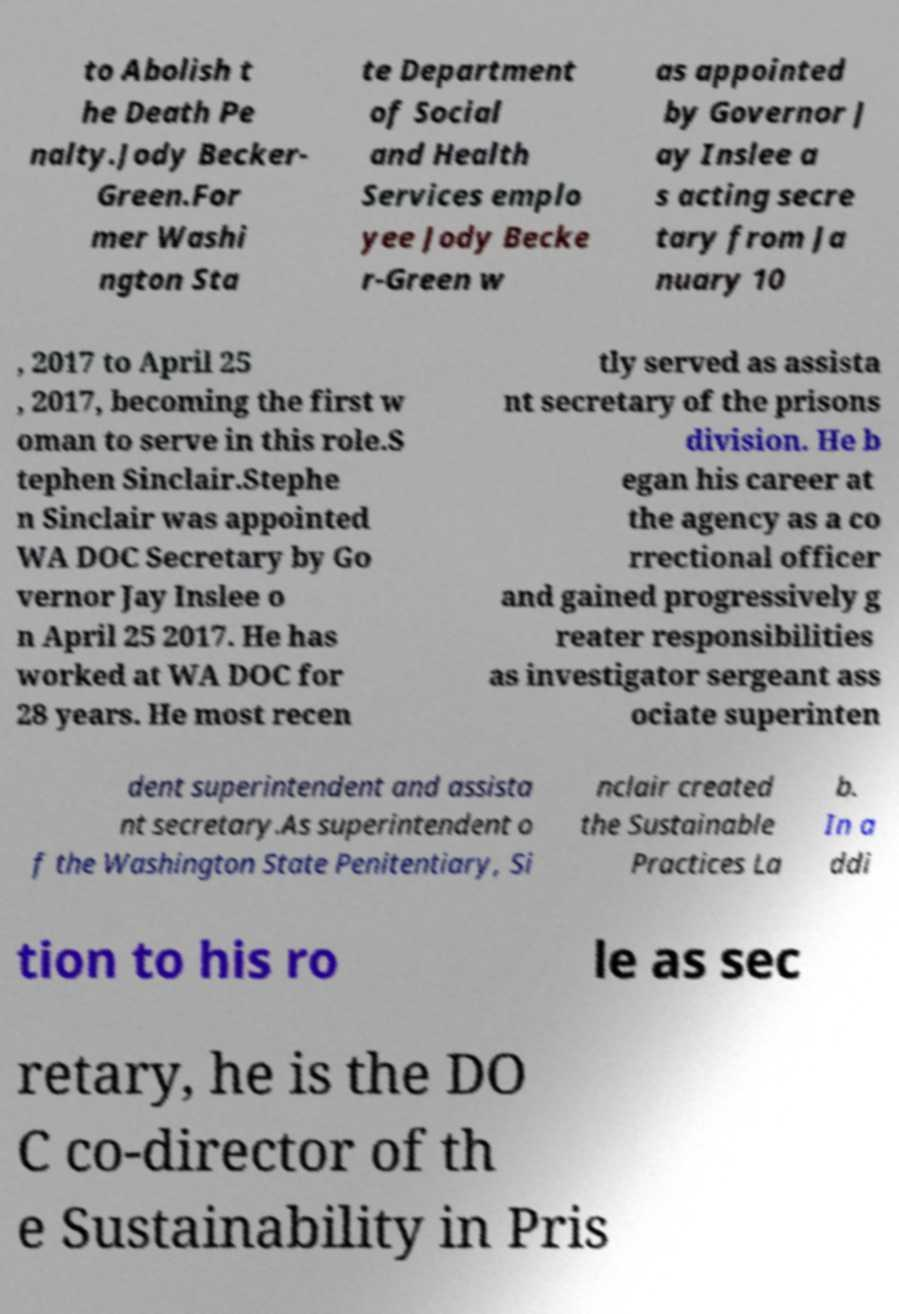Could you assist in decoding the text presented in this image and type it out clearly? to Abolish t he Death Pe nalty.Jody Becker- Green.For mer Washi ngton Sta te Department of Social and Health Services emplo yee Jody Becke r-Green w as appointed by Governor J ay Inslee a s acting secre tary from Ja nuary 10 , 2017 to April 25 , 2017, becoming the first w oman to serve in this role.S tephen Sinclair.Stephe n Sinclair was appointed WA DOC Secretary by Go vernor Jay Inslee o n April 25 2017. He has worked at WA DOC for 28 years. He most recen tly served as assista nt secretary of the prisons division. He b egan his career at the agency as a co rrectional officer and gained progressively g reater responsibilities as investigator sergeant ass ociate superinten dent superintendent and assista nt secretary.As superintendent o f the Washington State Penitentiary, Si nclair created the Sustainable Practices La b. In a ddi tion to his ro le as sec retary, he is the DO C co-director of th e Sustainability in Pris 